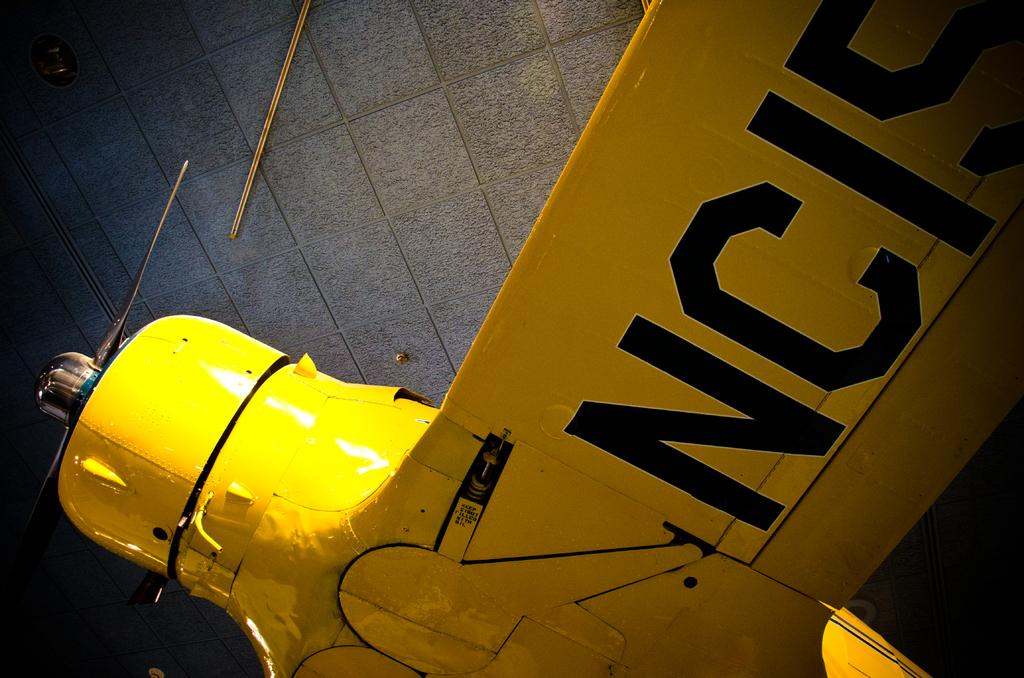<image>
Write a terse but informative summary of the picture. A yellow plane with the propeller with NCIS sign on it. 